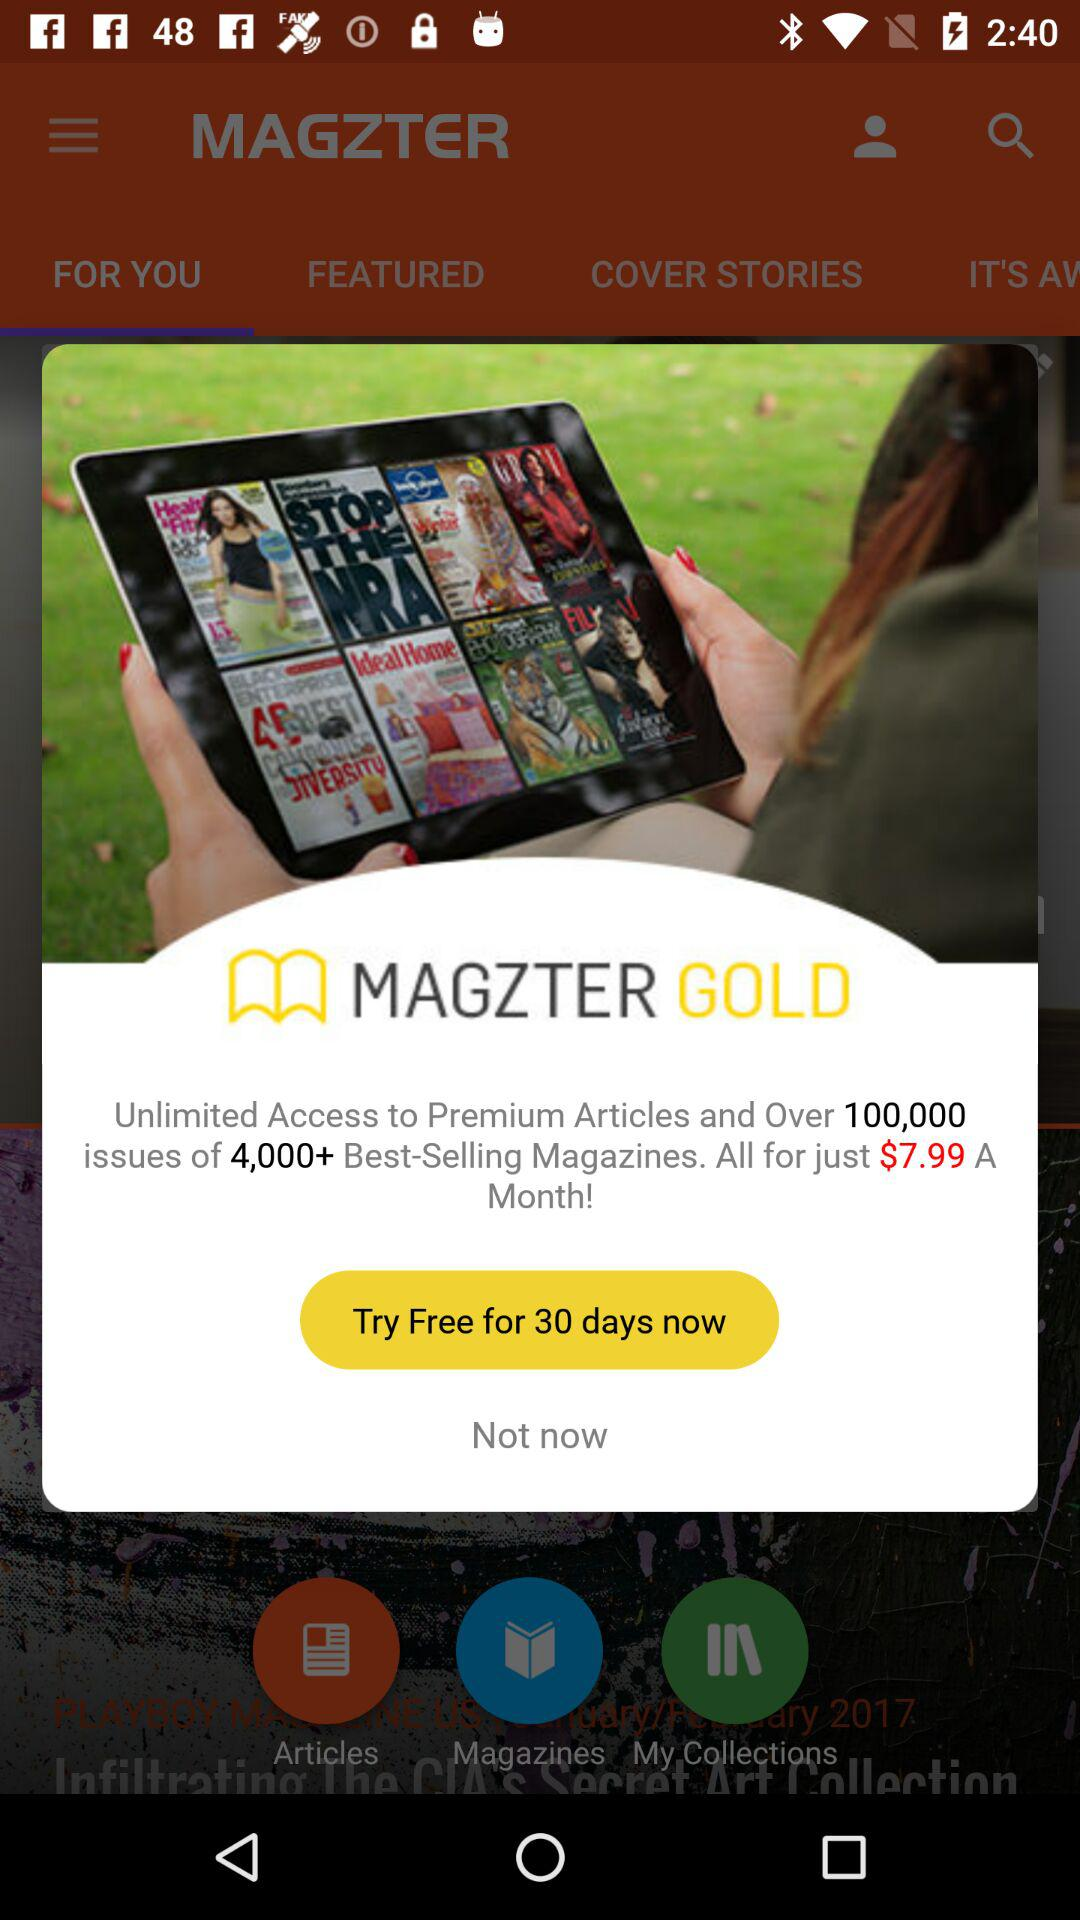What is the monthly price for all magazines? The monthly price is $7.99. 